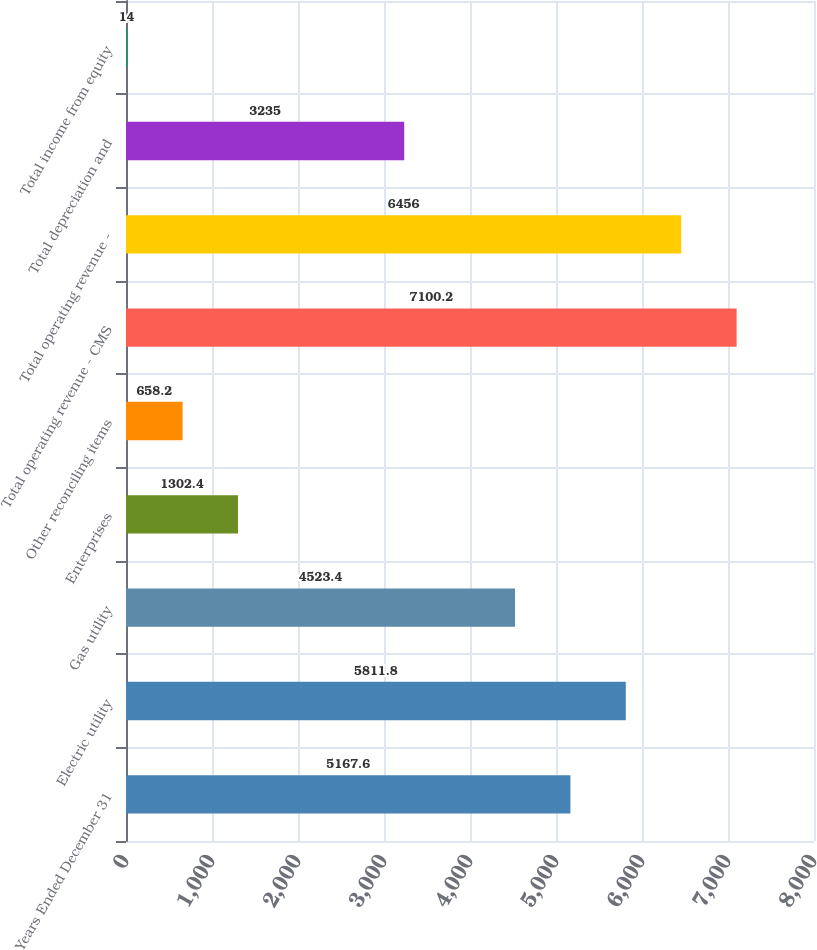Convert chart. <chart><loc_0><loc_0><loc_500><loc_500><bar_chart><fcel>Years Ended December 31<fcel>Electric utility<fcel>Gas utility<fcel>Enterprises<fcel>Other reconciling items<fcel>Total operating revenue - CMS<fcel>Total operating revenue -<fcel>Total depreciation and<fcel>Total income from equity<nl><fcel>5167.6<fcel>5811.8<fcel>4523.4<fcel>1302.4<fcel>658.2<fcel>7100.2<fcel>6456<fcel>3235<fcel>14<nl></chart> 